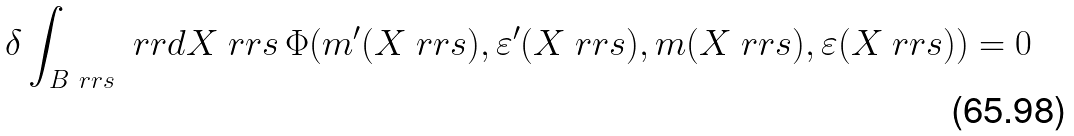Convert formula to latex. <formula><loc_0><loc_0><loc_500><loc_500>\delta \int _ { B _ { \ } r r { s } } \ r r { d } X _ { \ } r r { s } \, \Phi ( m ^ { \prime } ( X _ { \ } r r { s } ) , \varepsilon ^ { \prime } ( X _ { \ } r r { s } ) , m ( X _ { \ } r r { s } ) , \varepsilon ( X _ { \ } r r { s } ) ) = 0</formula> 